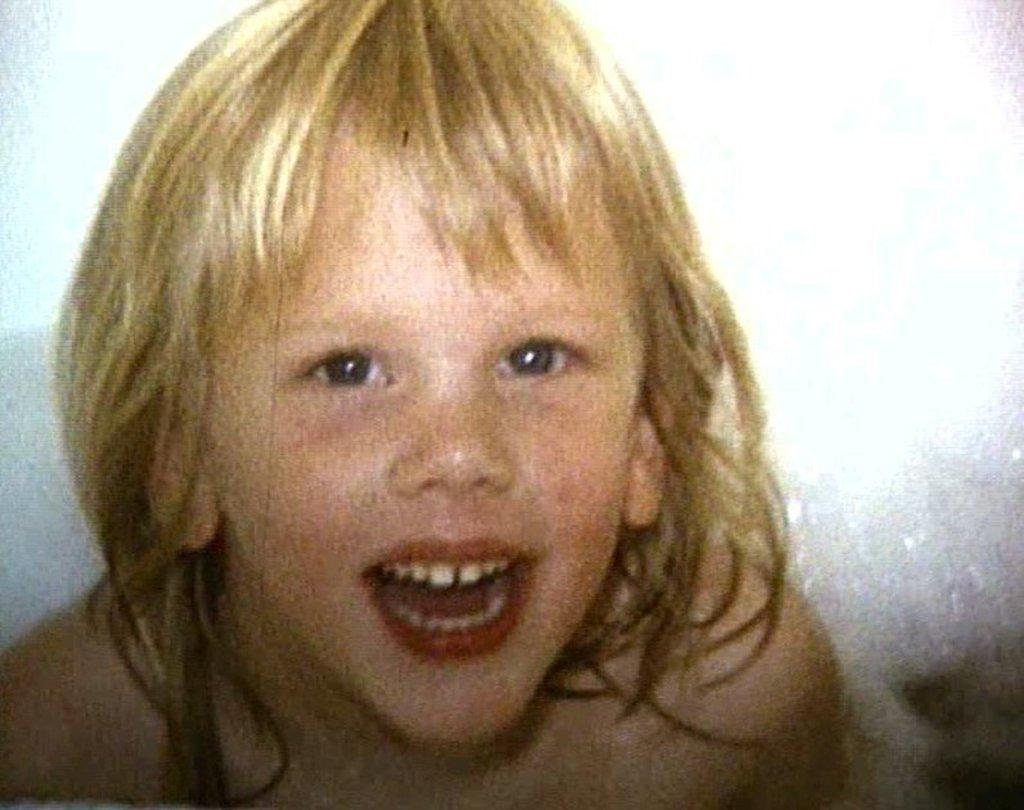What is the main subject of the image? The main subject of the image is a kid. Where is the kid located in the image? The kid is in the center of the image. What is the kid's expression in the image? The kid is smiling in the image. What type of prison can be seen in the background of the image? There is no prison present in the image; it features a kid in the center of the frame. How many bubbles are surrounding the kid in the image? There are no bubbles present in the image; it only features the kid in the center. 